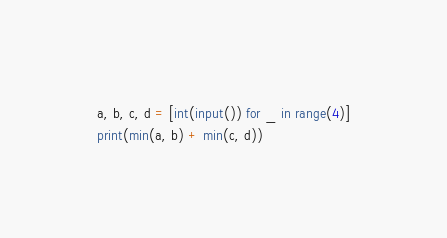<code> <loc_0><loc_0><loc_500><loc_500><_Python_>a, b, c, d = [int(input()) for _ in range(4)]
print(min(a, b) + min(c, d))</code> 